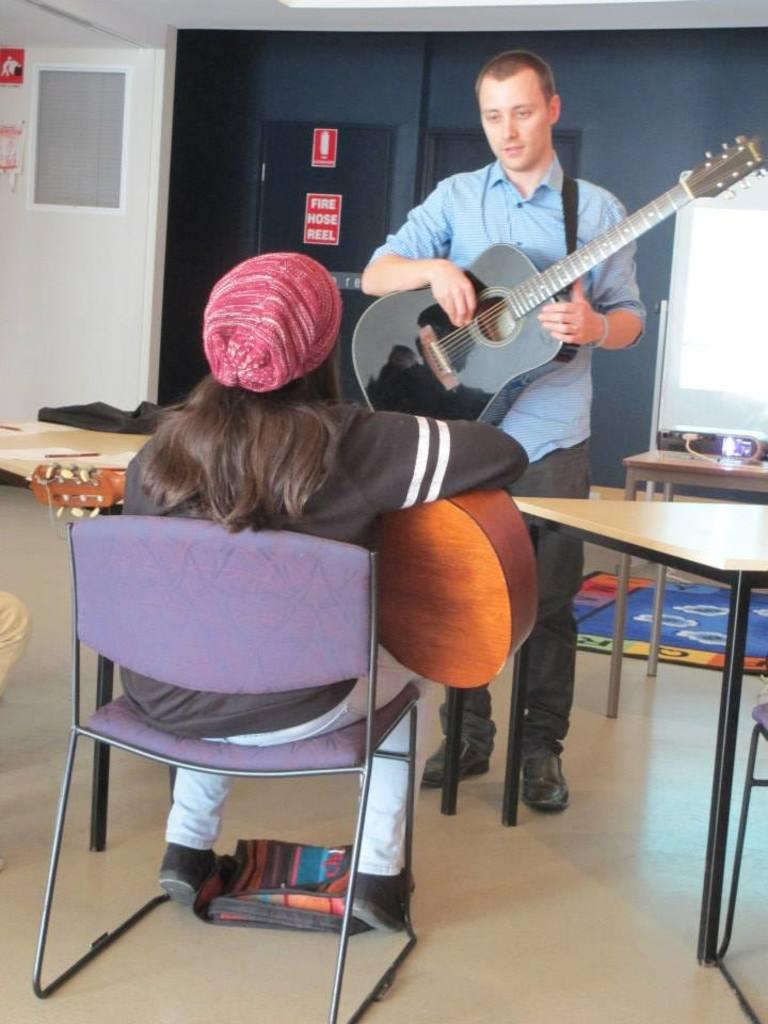What is the seated person doing in the image? The seated person is holding a guitar. What is the standing person doing in the image? The standing person is holding a black guitar. Can you describe the interaction between the two people in the image? The standing person is in front of the seated person, suggesting they might be playing or discussing the guitars. Are there any fairies visible in the image? No, there are no fairies present in the image. What type of trail can be seen in the image? There is no trail visible in the image; it features two people with guitars. 